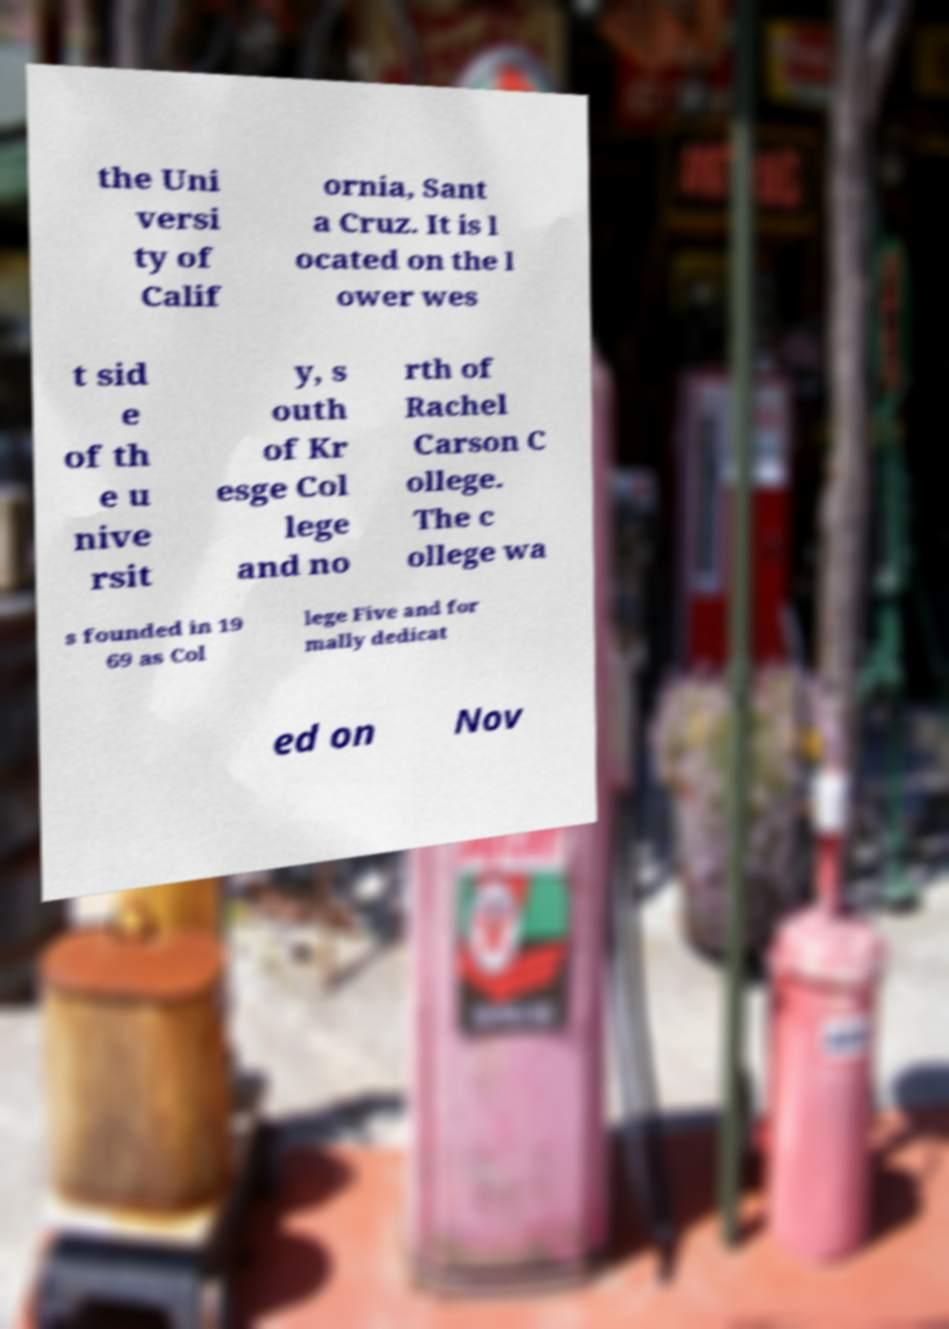Could you extract and type out the text from this image? the Uni versi ty of Calif ornia, Sant a Cruz. It is l ocated on the l ower wes t sid e of th e u nive rsit y, s outh of Kr esge Col lege and no rth of Rachel Carson C ollege. The c ollege wa s founded in 19 69 as Col lege Five and for mally dedicat ed on Nov 